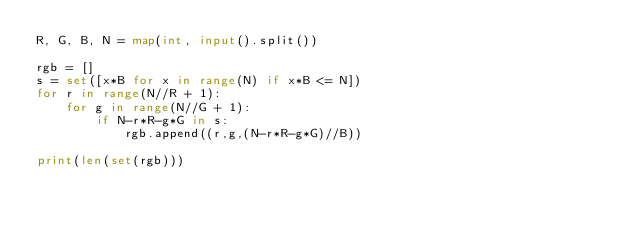Convert code to text. <code><loc_0><loc_0><loc_500><loc_500><_Python_>R, G, B, N = map(int, input().split())

rgb = []
s = set([x*B for x in range(N) if x*B <= N])
for r in range(N//R + 1):
    for g in range(N//G + 1):
        if N-r*R-g*G in s:
            rgb.append((r,g,(N-r*R-g*G)//B))

print(len(set(rgb)))</code> 